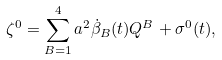Convert formula to latex. <formula><loc_0><loc_0><loc_500><loc_500>\zeta ^ { 0 } = \sum ^ { 4 } _ { B = 1 } a ^ { 2 } \dot { \beta } _ { B } ( t ) Q ^ { B } + \sigma ^ { 0 } ( t ) ,</formula> 